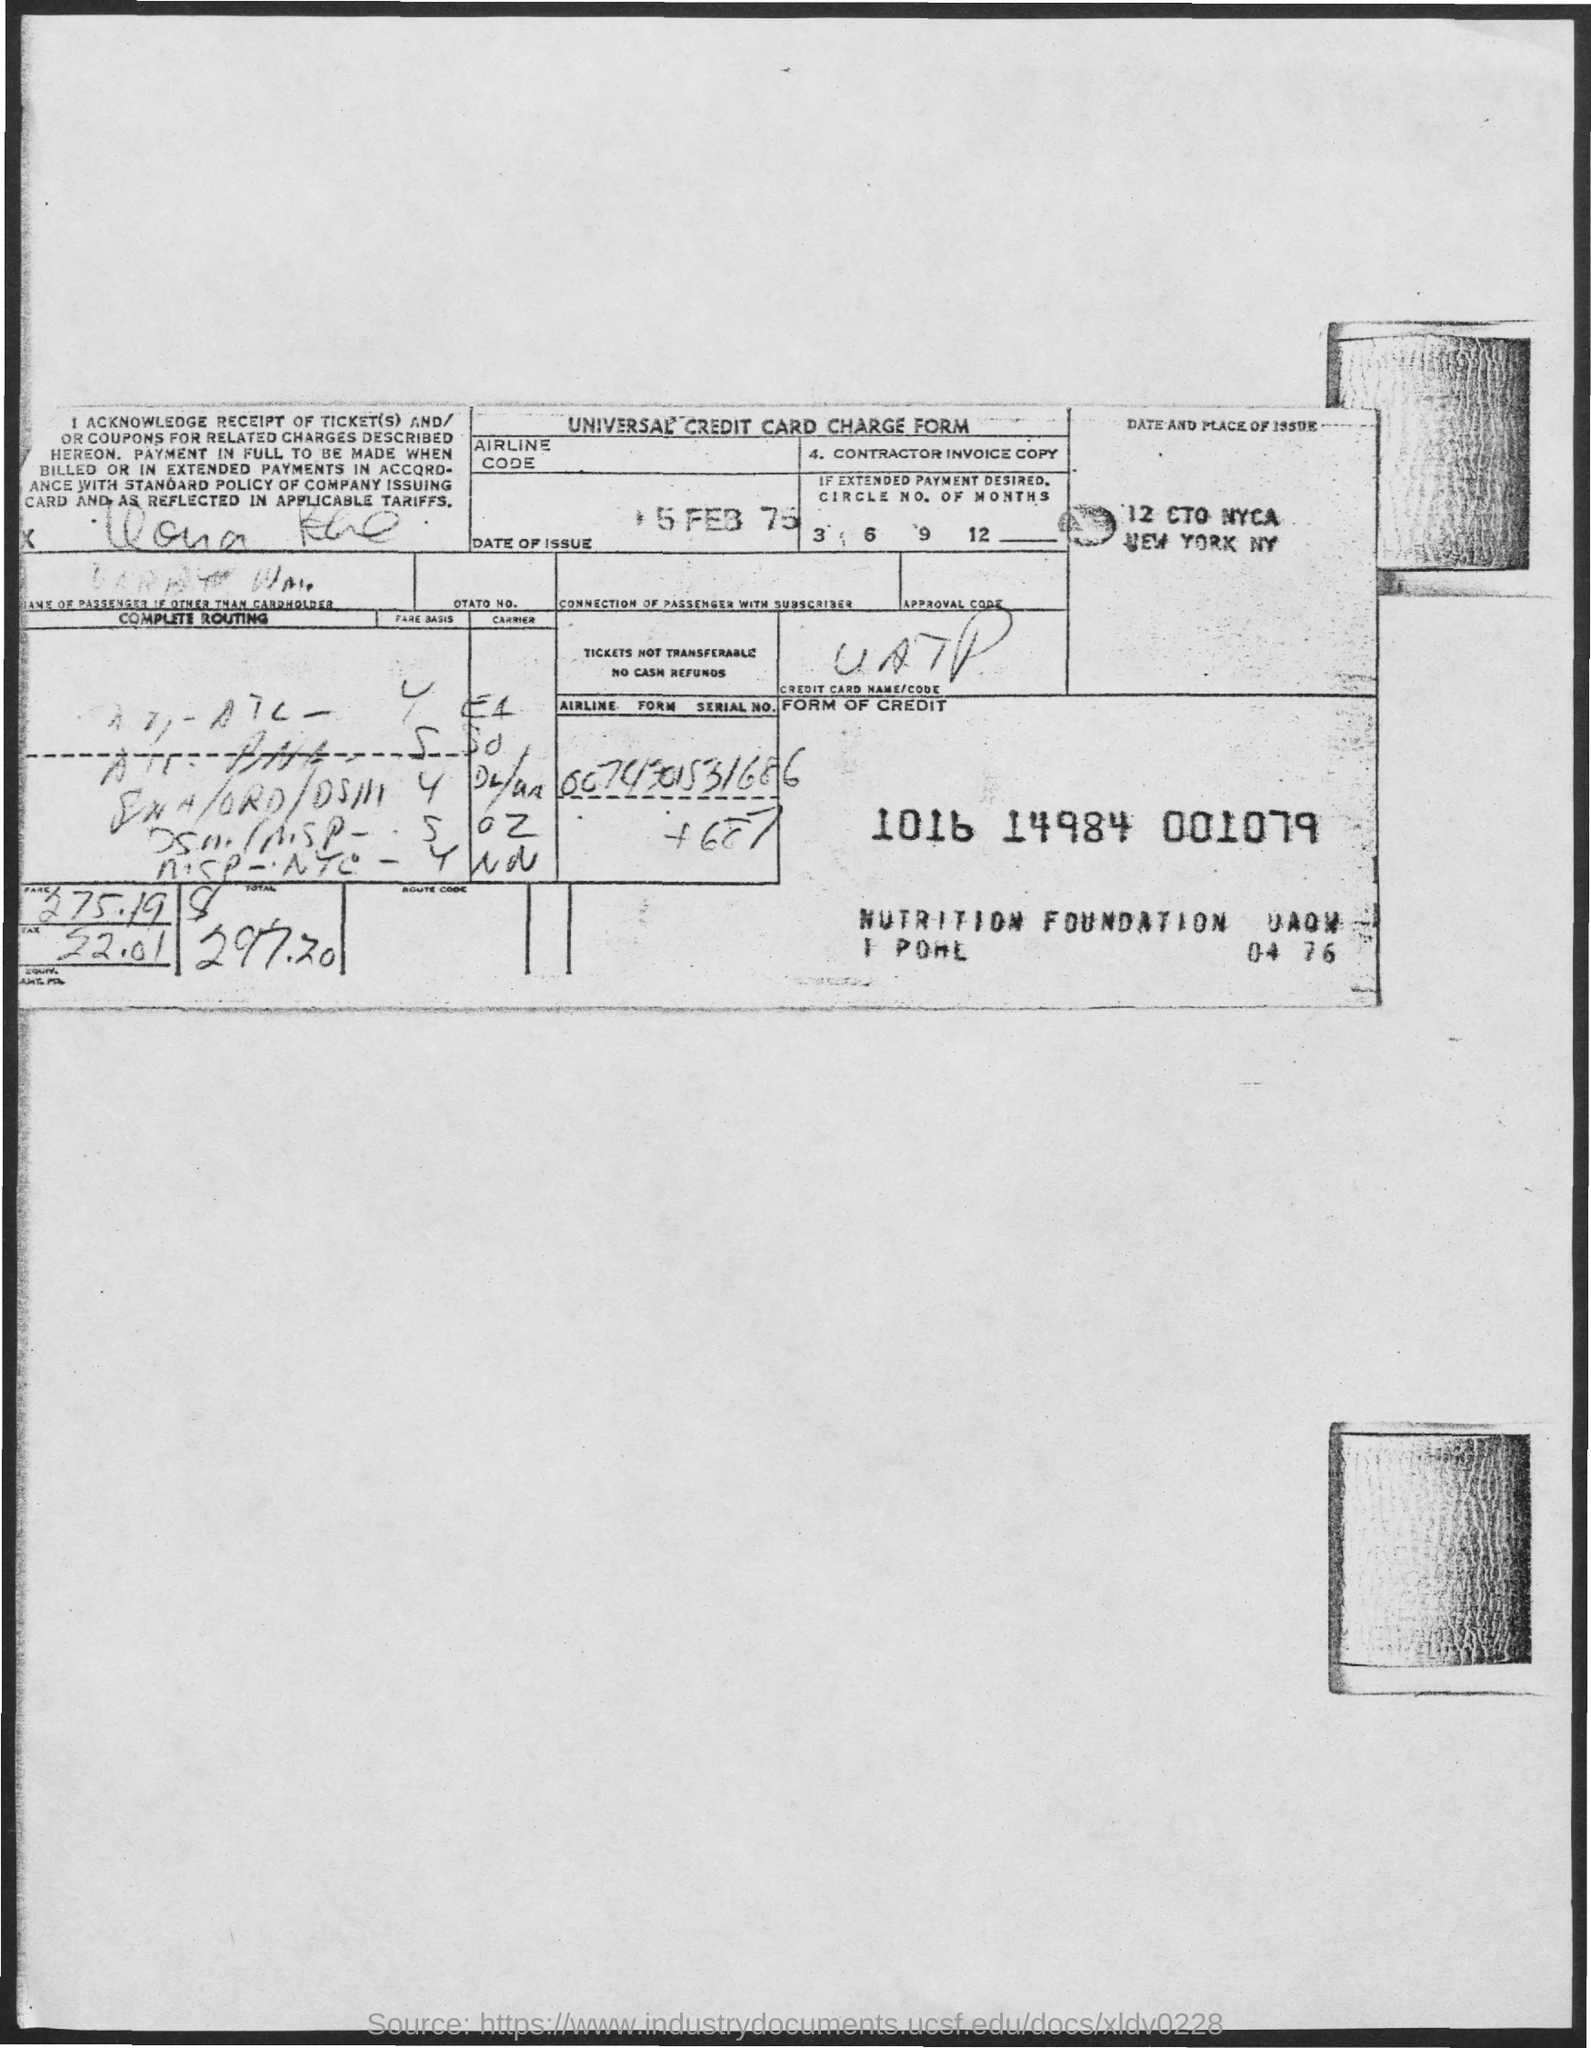Point out several critical features in this image. The tax amount is 52.01. The date of the issue is 5 February 1975. 